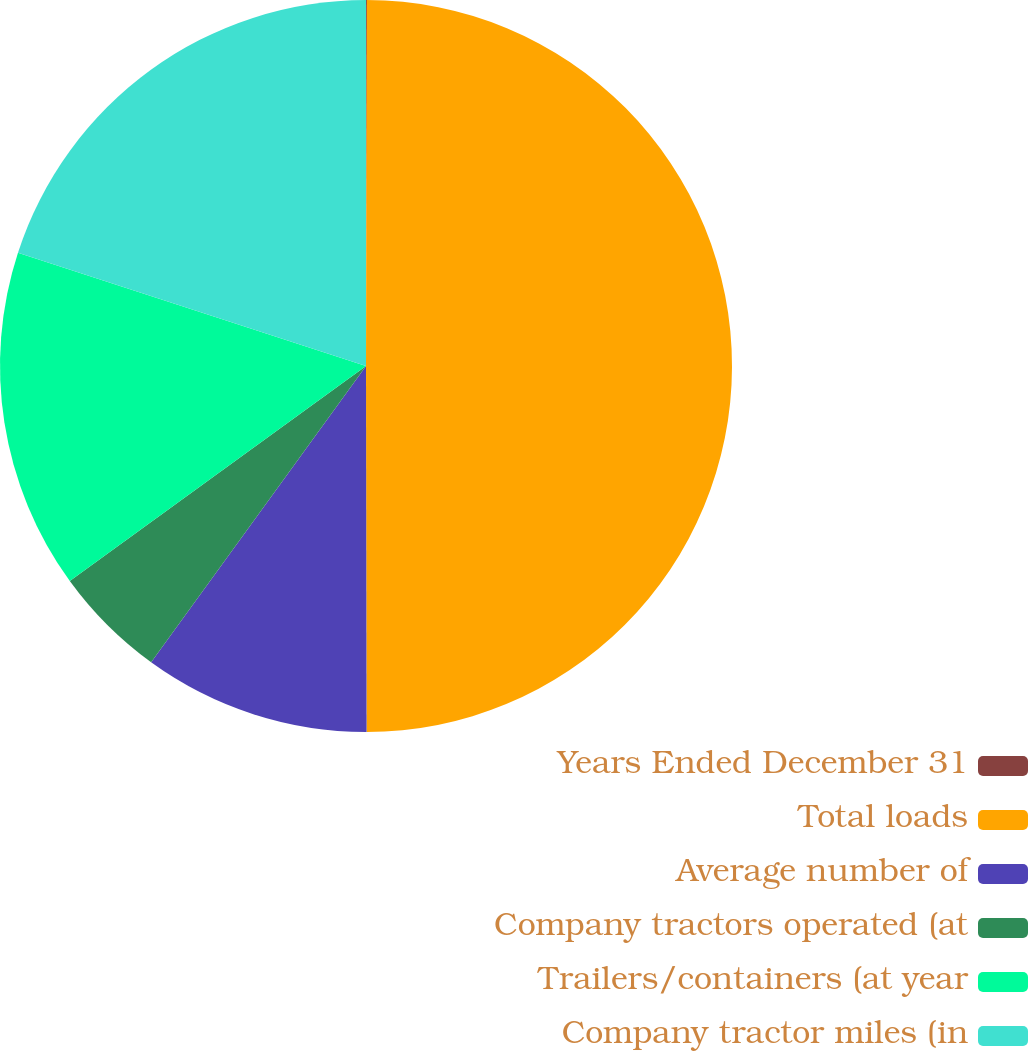Convert chart to OTSL. <chart><loc_0><loc_0><loc_500><loc_500><pie_chart><fcel>Years Ended December 31<fcel>Total loads<fcel>Average number of<fcel>Company tractors operated (at<fcel>Trailers/containers (at year<fcel>Company tractor miles (in<nl><fcel>0.04%<fcel>49.93%<fcel>10.01%<fcel>5.02%<fcel>15.0%<fcel>19.99%<nl></chart> 